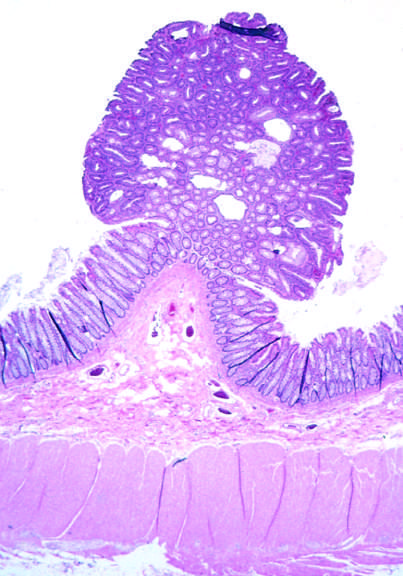re cm presented in this field?
Answer the question using a single word or phrase. No 